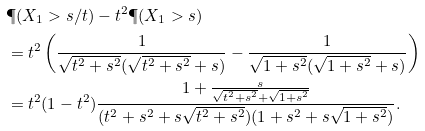Convert formula to latex. <formula><loc_0><loc_0><loc_500><loc_500>& \P ( X _ { 1 } > s / t ) - t ^ { 2 } \P ( X _ { 1 } > s ) \\ & = t ^ { 2 } \left ( \frac { 1 } { \sqrt { t ^ { 2 } + s ^ { 2 } } ( \sqrt { t ^ { 2 } + s ^ { 2 } } + s ) } - \frac { 1 } { \sqrt { 1 + s ^ { 2 } } ( \sqrt { 1 + s ^ { 2 } } + s ) } \right ) \\ & = t ^ { 2 } ( 1 - t ^ { 2 } ) \frac { 1 + \frac { s } { \sqrt { t ^ { 2 } + s ^ { 2 } } + \sqrt { 1 + s ^ { 2 } } } } { ( t ^ { 2 } + s ^ { 2 } + s \sqrt { t ^ { 2 } + s ^ { 2 } } ) ( 1 + s ^ { 2 } + s \sqrt { 1 + s ^ { 2 } } ) } .</formula> 